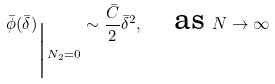<formula> <loc_0><loc_0><loc_500><loc_500>\bar { \phi } ( \bar { \delta } ) _ { \Big | N _ { 2 } = 0 } \sim \frac { \bar { C } } { 2 } \bar { \delta } ^ { 2 } , \quad \text {as } N \to \infty</formula> 